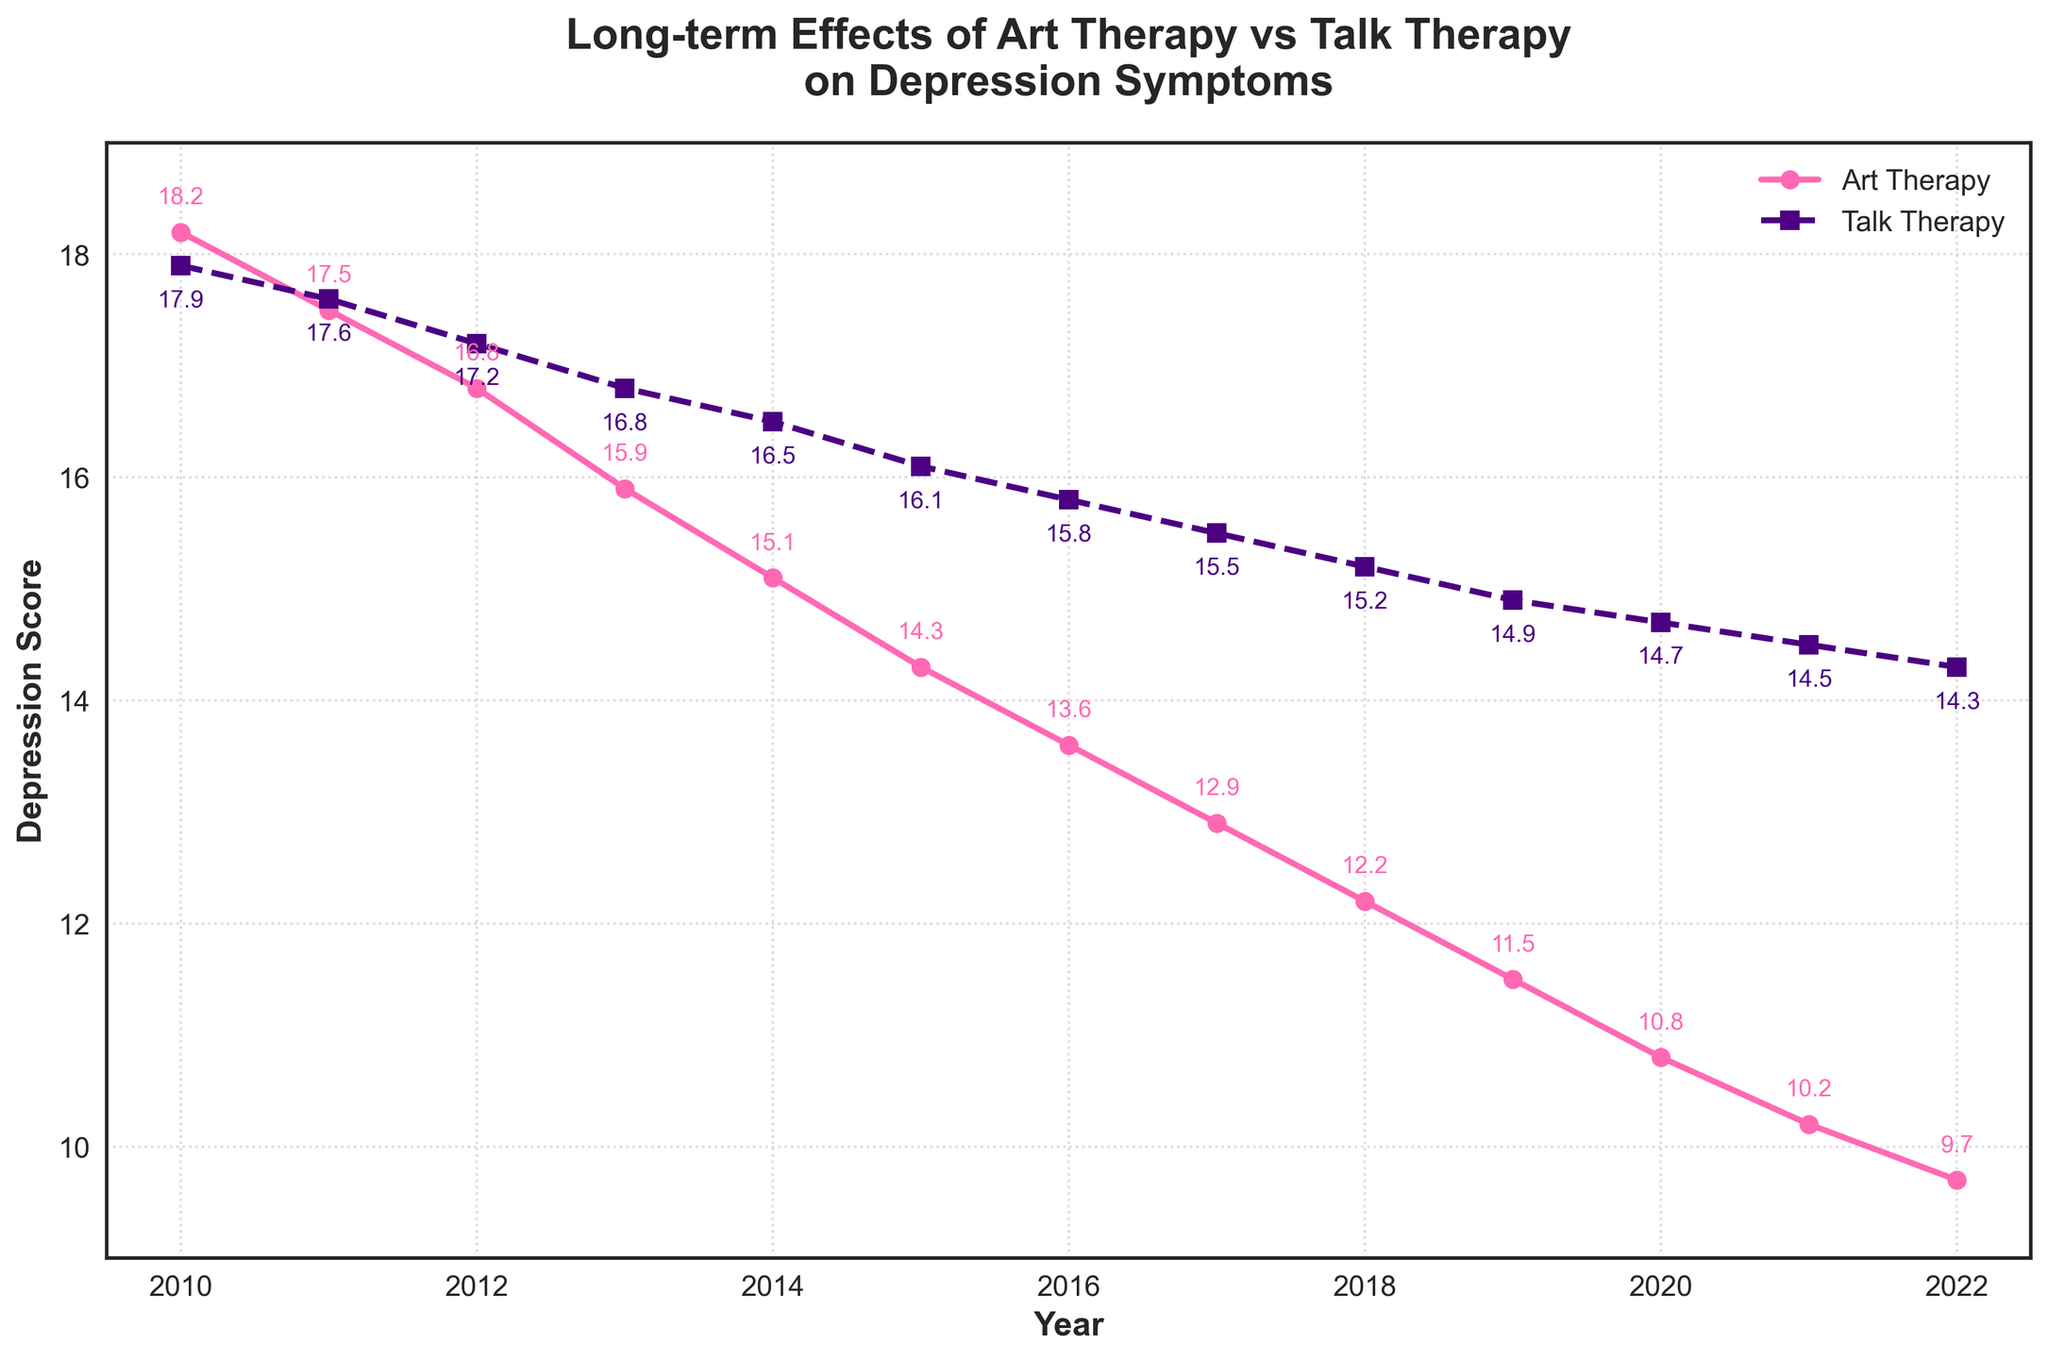What trend do you observe in the depression scores for art therapy from 2010 to 2022? The depression scores for art therapy consistently decrease from 18.2 in 2010 to 9.7 in 2022. This steady decline indicates an improvement in depression symptoms over time with art therapy.
Answer: Consistent decrease Which therapy, art or talk, shows a greater reduction in depression scores by 2022? To determine the greater reduction, calculate the difference in scores from 2010 to 2022 for both therapies. Art therapy reduced from 18.2 to 9.7 (18.2 - 9.7 = 8.5), while talk therapy reduced from 17.9 to 14.3 (17.9 - 14.3 = 3.6). Art therapy shows a greater reduction.
Answer: Art therapy In which year do the depression scores for art therapy first drop below 15? Observing the line for art therapy, the scores drop below 15 in the year 2015. The score in 2015 is 14.3.
Answer: 2015 How do the scores for talk therapy in 2022 compare to those for art therapy in 2016? The score for talk therapy in 2022 is 14.3, and the score for art therapy in 2016 is 13.6. 14.3 (talk therapy) is higher than 13.6 (art therapy).
Answer: Higher What is the visual difference between the lines representing art therapy and talk therapy on the graph? The art therapy line is shown with circles and is solid pink, while the talk therapy line is shown with squares and is dashed purple.
Answer: Different markers and line styles What is the average depression score reduction per year for art therapy? Calculate the total reduction (18.2 - 9.7 = 8.5) and divide by the number of years (2022 - 2010 = 12). 8.5/12 ≈ 0.71.
Answer: Approximately 0.71 Which year shows the closest depression scores between art therapy and talk therapy? Check the values year by year: the closest difference is in 2010, with scores of 18.2 (art) and 17.9 (talk), yielding a difference of 0.3.
Answer: 2010 Describe the change in depression score for talk therapy from 2018 to 2022. In 2018, the score is 15.2. By 2022, the score is 14.3. The difference is 15.2 - 14.3 = 0.9, indicating a reduction of 0.9.
Answer: Decrease by 0.9 In 2014, by how much did the art therapy depression score differ from the talk therapy score? The 2014 art therapy score is 15.1, and the talk therapy score is 16.5. The difference is 16.5 - 15.1 = 1.4.
Answer: 1.4 By how much did the talk therapy depression score change between 2010 and 2022? The scores are 17.9 in 2010 and 14.3 in 2022. The change is 17.9 - 14.3 = 3.6, indicating a reduction.
Answer: Reduction of 3.6 